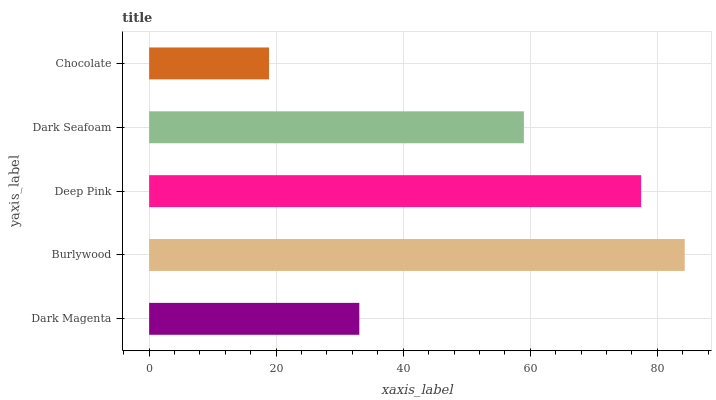Is Chocolate the minimum?
Answer yes or no. Yes. Is Burlywood the maximum?
Answer yes or no. Yes. Is Deep Pink the minimum?
Answer yes or no. No. Is Deep Pink the maximum?
Answer yes or no. No. Is Burlywood greater than Deep Pink?
Answer yes or no. Yes. Is Deep Pink less than Burlywood?
Answer yes or no. Yes. Is Deep Pink greater than Burlywood?
Answer yes or no. No. Is Burlywood less than Deep Pink?
Answer yes or no. No. Is Dark Seafoam the high median?
Answer yes or no. Yes. Is Dark Seafoam the low median?
Answer yes or no. Yes. Is Burlywood the high median?
Answer yes or no. No. Is Deep Pink the low median?
Answer yes or no. No. 